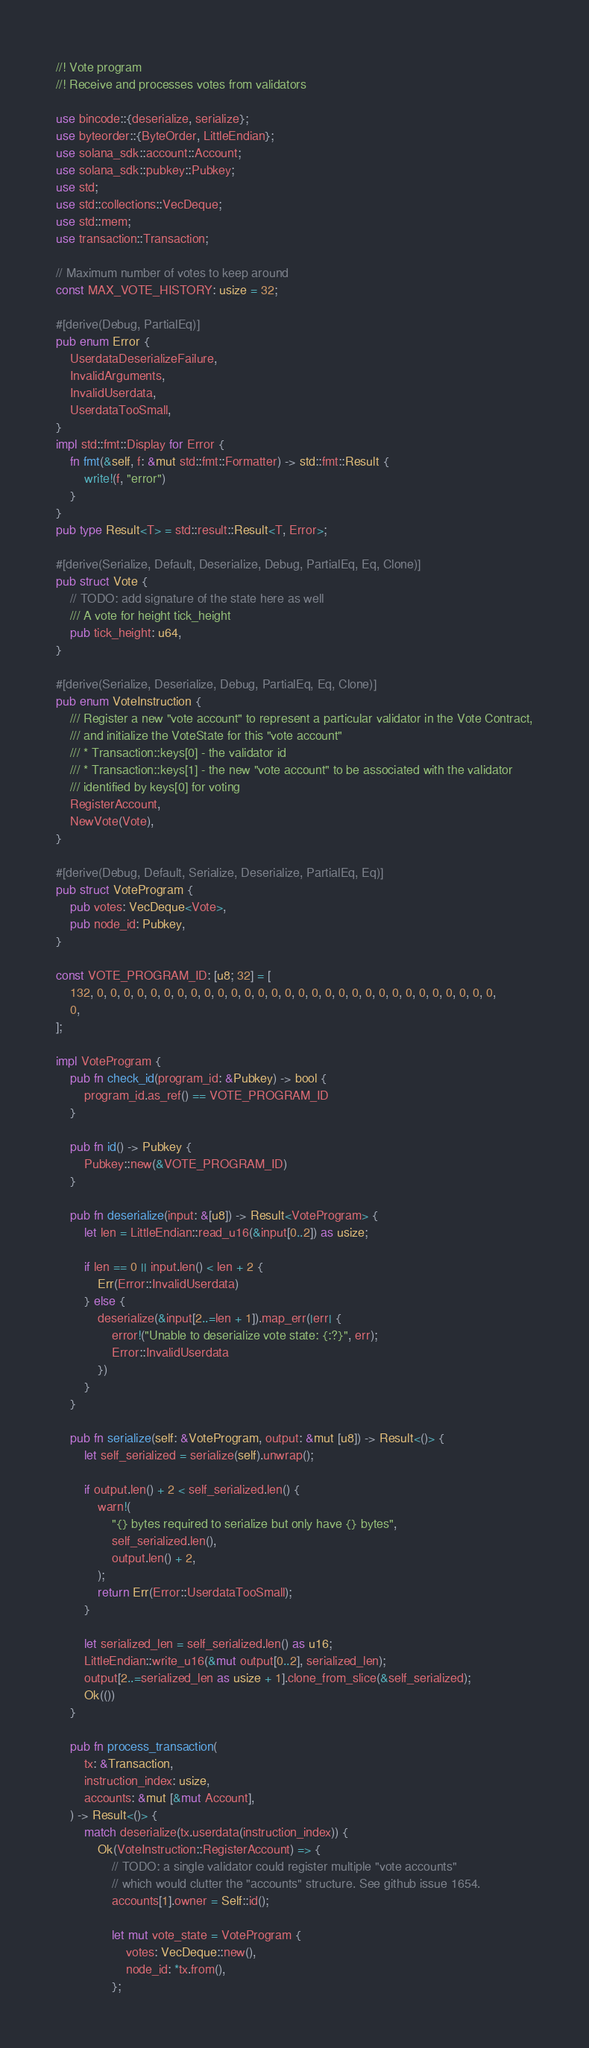<code> <loc_0><loc_0><loc_500><loc_500><_Rust_>//! Vote program
//! Receive and processes votes from validators

use bincode::{deserialize, serialize};
use byteorder::{ByteOrder, LittleEndian};
use solana_sdk::account::Account;
use solana_sdk::pubkey::Pubkey;
use std;
use std::collections::VecDeque;
use std::mem;
use transaction::Transaction;

// Maximum number of votes to keep around
const MAX_VOTE_HISTORY: usize = 32;

#[derive(Debug, PartialEq)]
pub enum Error {
    UserdataDeserializeFailure,
    InvalidArguments,
    InvalidUserdata,
    UserdataTooSmall,
}
impl std::fmt::Display for Error {
    fn fmt(&self, f: &mut std::fmt::Formatter) -> std::fmt::Result {
        write!(f, "error")
    }
}
pub type Result<T> = std::result::Result<T, Error>;

#[derive(Serialize, Default, Deserialize, Debug, PartialEq, Eq, Clone)]
pub struct Vote {
    // TODO: add signature of the state here as well
    /// A vote for height tick_height
    pub tick_height: u64,
}

#[derive(Serialize, Deserialize, Debug, PartialEq, Eq, Clone)]
pub enum VoteInstruction {
    /// Register a new "vote account" to represent a particular validator in the Vote Contract,
    /// and initialize the VoteState for this "vote account"
    /// * Transaction::keys[0] - the validator id
    /// * Transaction::keys[1] - the new "vote account" to be associated with the validator
    /// identified by keys[0] for voting
    RegisterAccount,
    NewVote(Vote),
}

#[derive(Debug, Default, Serialize, Deserialize, PartialEq, Eq)]
pub struct VoteProgram {
    pub votes: VecDeque<Vote>,
    pub node_id: Pubkey,
}

const VOTE_PROGRAM_ID: [u8; 32] = [
    132, 0, 0, 0, 0, 0, 0, 0, 0, 0, 0, 0, 0, 0, 0, 0, 0, 0, 0, 0, 0, 0, 0, 0, 0, 0, 0, 0, 0, 0, 0,
    0,
];

impl VoteProgram {
    pub fn check_id(program_id: &Pubkey) -> bool {
        program_id.as_ref() == VOTE_PROGRAM_ID
    }

    pub fn id() -> Pubkey {
        Pubkey::new(&VOTE_PROGRAM_ID)
    }

    pub fn deserialize(input: &[u8]) -> Result<VoteProgram> {
        let len = LittleEndian::read_u16(&input[0..2]) as usize;

        if len == 0 || input.len() < len + 2 {
            Err(Error::InvalidUserdata)
        } else {
            deserialize(&input[2..=len + 1]).map_err(|err| {
                error!("Unable to deserialize vote state: {:?}", err);
                Error::InvalidUserdata
            })
        }
    }

    pub fn serialize(self: &VoteProgram, output: &mut [u8]) -> Result<()> {
        let self_serialized = serialize(self).unwrap();

        if output.len() + 2 < self_serialized.len() {
            warn!(
                "{} bytes required to serialize but only have {} bytes",
                self_serialized.len(),
                output.len() + 2,
            );
            return Err(Error::UserdataTooSmall);
        }

        let serialized_len = self_serialized.len() as u16;
        LittleEndian::write_u16(&mut output[0..2], serialized_len);
        output[2..=serialized_len as usize + 1].clone_from_slice(&self_serialized);
        Ok(())
    }

    pub fn process_transaction(
        tx: &Transaction,
        instruction_index: usize,
        accounts: &mut [&mut Account],
    ) -> Result<()> {
        match deserialize(tx.userdata(instruction_index)) {
            Ok(VoteInstruction::RegisterAccount) => {
                // TODO: a single validator could register multiple "vote accounts"
                // which would clutter the "accounts" structure. See github issue 1654.
                accounts[1].owner = Self::id();

                let mut vote_state = VoteProgram {
                    votes: VecDeque::new(),
                    node_id: *tx.from(),
                };
</code> 